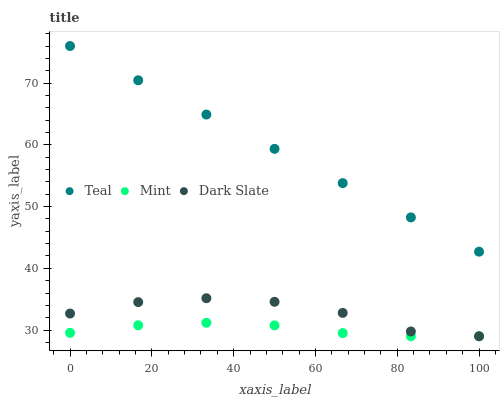Does Mint have the minimum area under the curve?
Answer yes or no. Yes. Does Teal have the maximum area under the curve?
Answer yes or no. Yes. Does Teal have the minimum area under the curve?
Answer yes or no. No. Does Mint have the maximum area under the curve?
Answer yes or no. No. Is Teal the smoothest?
Answer yes or no. Yes. Is Dark Slate the roughest?
Answer yes or no. Yes. Is Mint the smoothest?
Answer yes or no. No. Is Mint the roughest?
Answer yes or no. No. Does Dark Slate have the lowest value?
Answer yes or no. Yes. Does Teal have the lowest value?
Answer yes or no. No. Does Teal have the highest value?
Answer yes or no. Yes. Does Mint have the highest value?
Answer yes or no. No. Is Dark Slate less than Teal?
Answer yes or no. Yes. Is Teal greater than Dark Slate?
Answer yes or no. Yes. Does Mint intersect Dark Slate?
Answer yes or no. Yes. Is Mint less than Dark Slate?
Answer yes or no. No. Is Mint greater than Dark Slate?
Answer yes or no. No. Does Dark Slate intersect Teal?
Answer yes or no. No. 